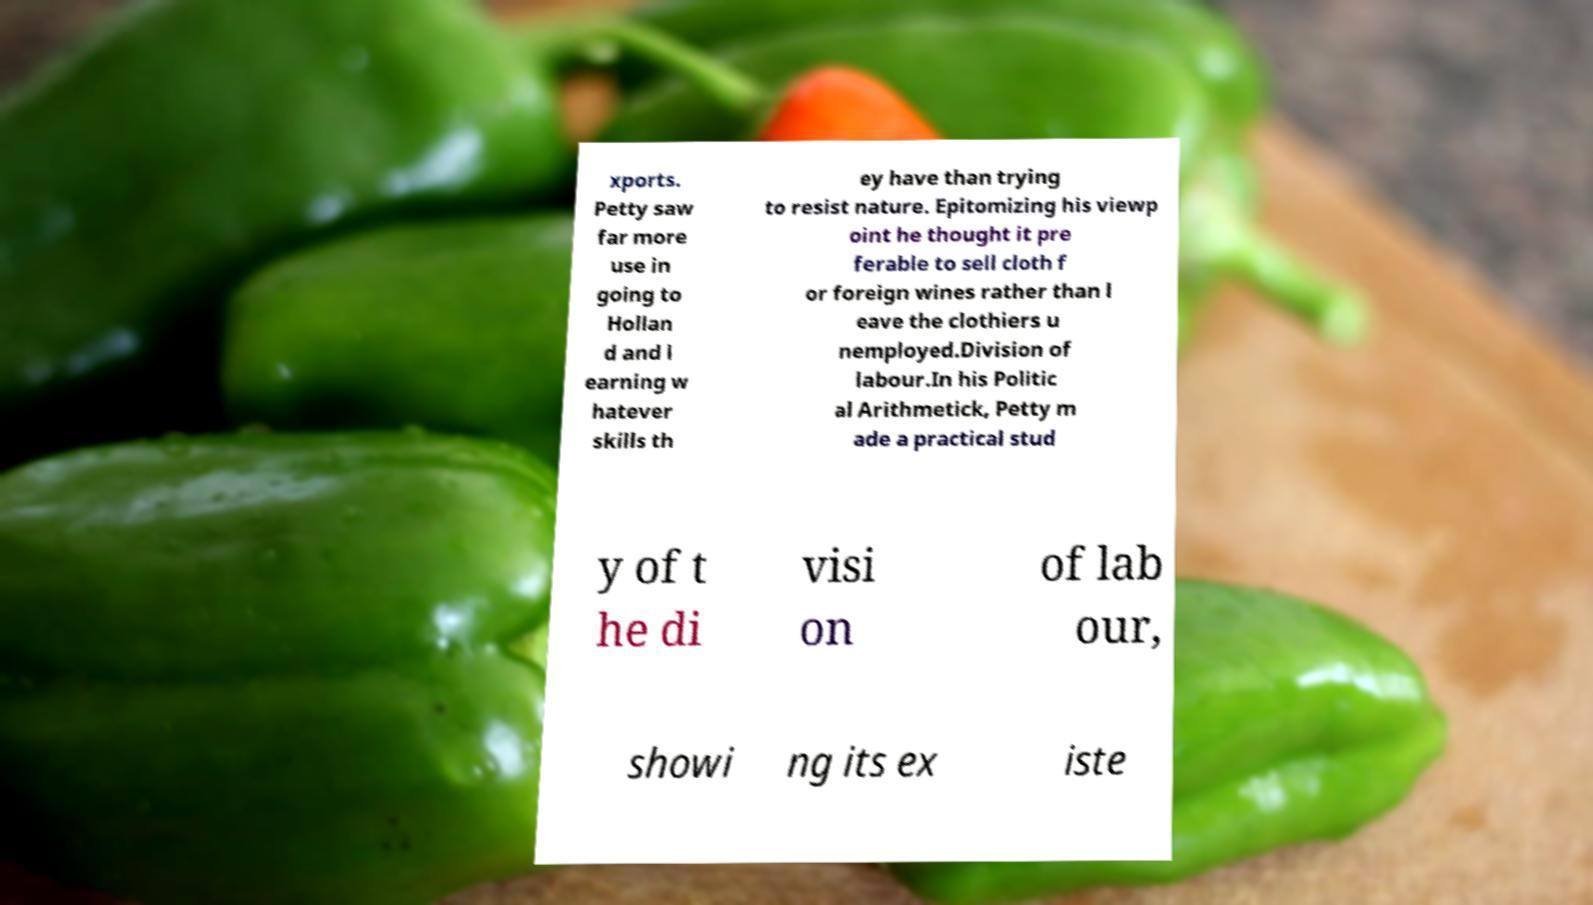Please read and relay the text visible in this image. What does it say? xports. Petty saw far more use in going to Hollan d and l earning w hatever skills th ey have than trying to resist nature. Epitomizing his viewp oint he thought it pre ferable to sell cloth f or foreign wines rather than l eave the clothiers u nemployed.Division of labour.In his Politic al Arithmetick, Petty m ade a practical stud y of t he di visi on of lab our, showi ng its ex iste 